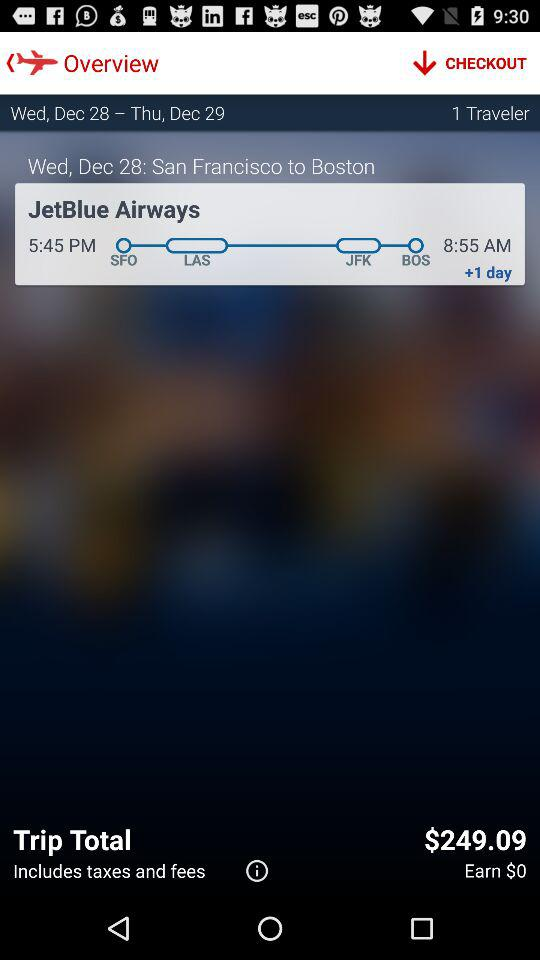What is the departure time of the flight? The departure time is 5:45 PM. 